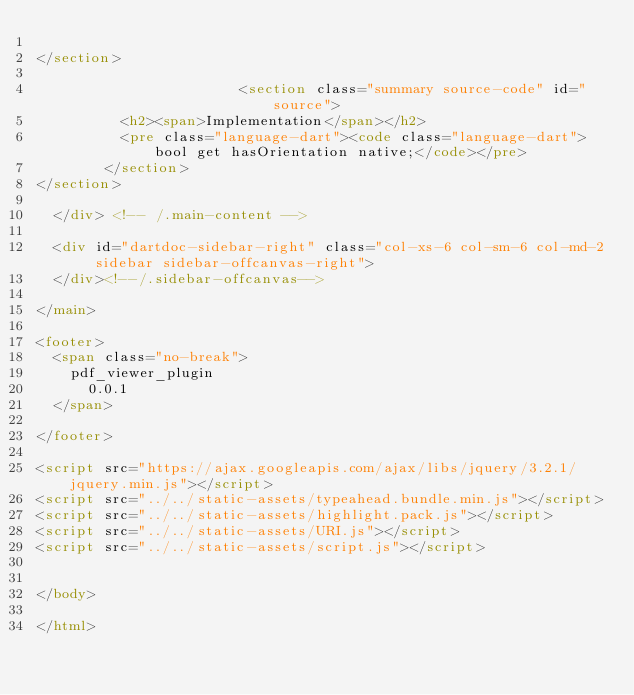Convert code to text. <code><loc_0><loc_0><loc_500><loc_500><_HTML_>          
</section>
        
                        <section class="summary source-code" id="source">
          <h2><span>Implementation</span></h2>
          <pre class="language-dart"><code class="language-dart">bool get hasOrientation native;</code></pre>
        </section>
</section>
        
  </div> <!-- /.main-content -->

  <div id="dartdoc-sidebar-right" class="col-xs-6 col-sm-6 col-md-2 sidebar sidebar-offcanvas-right">
  </div><!--/.sidebar-offcanvas-->

</main>

<footer>
  <span class="no-break">
    pdf_viewer_plugin
      0.0.1
  </span>

</footer>

<script src="https://ajax.googleapis.com/ajax/libs/jquery/3.2.1/jquery.min.js"></script>
<script src="../../static-assets/typeahead.bundle.min.js"></script>
<script src="../../static-assets/highlight.pack.js"></script>
<script src="../../static-assets/URI.js"></script>
<script src="../../static-assets/script.js"></script>


</body>

</html>
</code> 